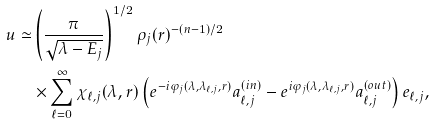Convert formula to latex. <formula><loc_0><loc_0><loc_500><loc_500>u \simeq & \left ( \frac { \pi } { \sqrt { \lambda - E _ { j } } } \right ) ^ { 1 / 2 } \rho _ { j } ( r ) ^ { - ( n - 1 ) / 2 } \\ & \times \sum _ { \ell = 0 } ^ { \infty } \chi _ { \ell , j } ( \lambda , r ) \left ( e ^ { - i \varphi _ { j } ( \lambda , \lambda _ { \ell , j } , r ) } a ^ { ( i n ) } _ { \ell , j } - e ^ { i \varphi _ { j } ( \lambda , \lambda _ { \ell , j } , r ) } a ^ { ( o u t ) } _ { \ell , j } \right ) e _ { \ell , j } ,</formula> 